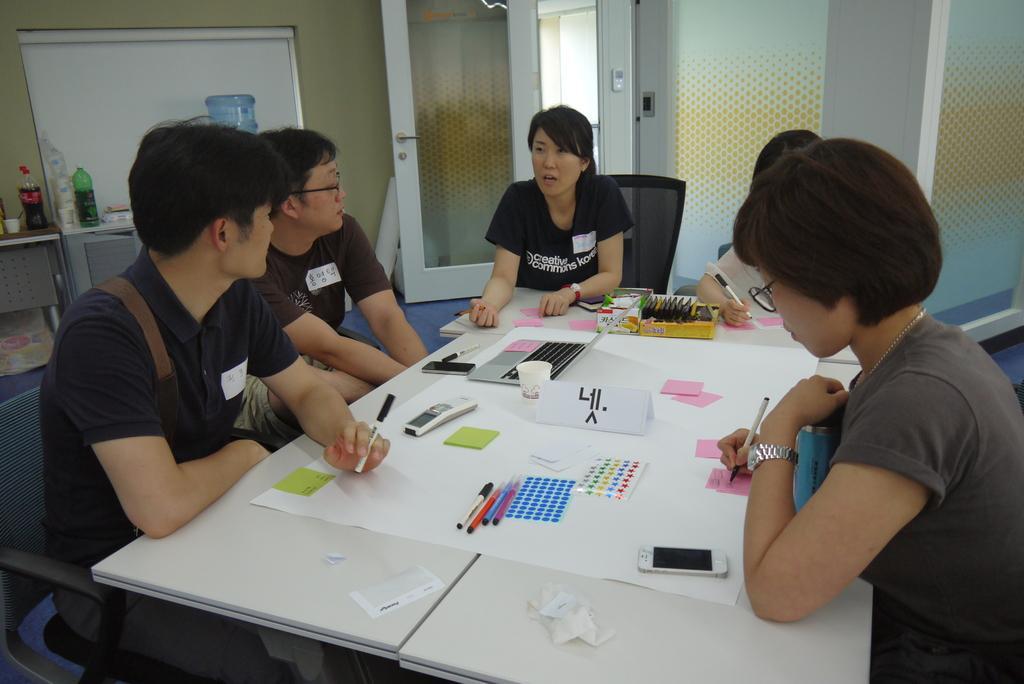In one or two sentences, can you explain what this image depicts? In this image we can see few people are sitting on the chairs around the table. On the table we can see papers, laptop, mobiles, remote, markers, and few objects. In the background we can see wallboard, bottles, tables, water in, door, and glasses. 